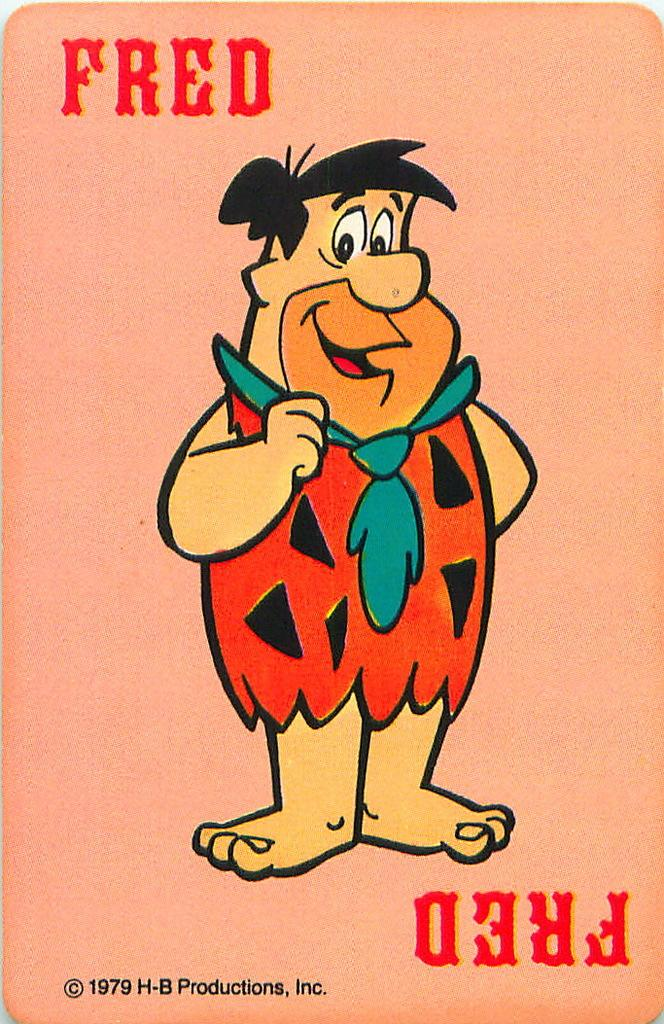What is depicted in the image? There is a drawing of a person in the image. What is the person wearing? The person is wearing a red dress and a tie. What is the facial expression of the person? The person is smiling. Where is the person standing? The person is standing on the ground. What else can be seen in the image besides the person? There is text printed on the image. What type of government is depicted in the image? There is no depiction of a government in the image; it features a drawing of a person wearing a red dress, a tie, and smiling while standing on the ground. 